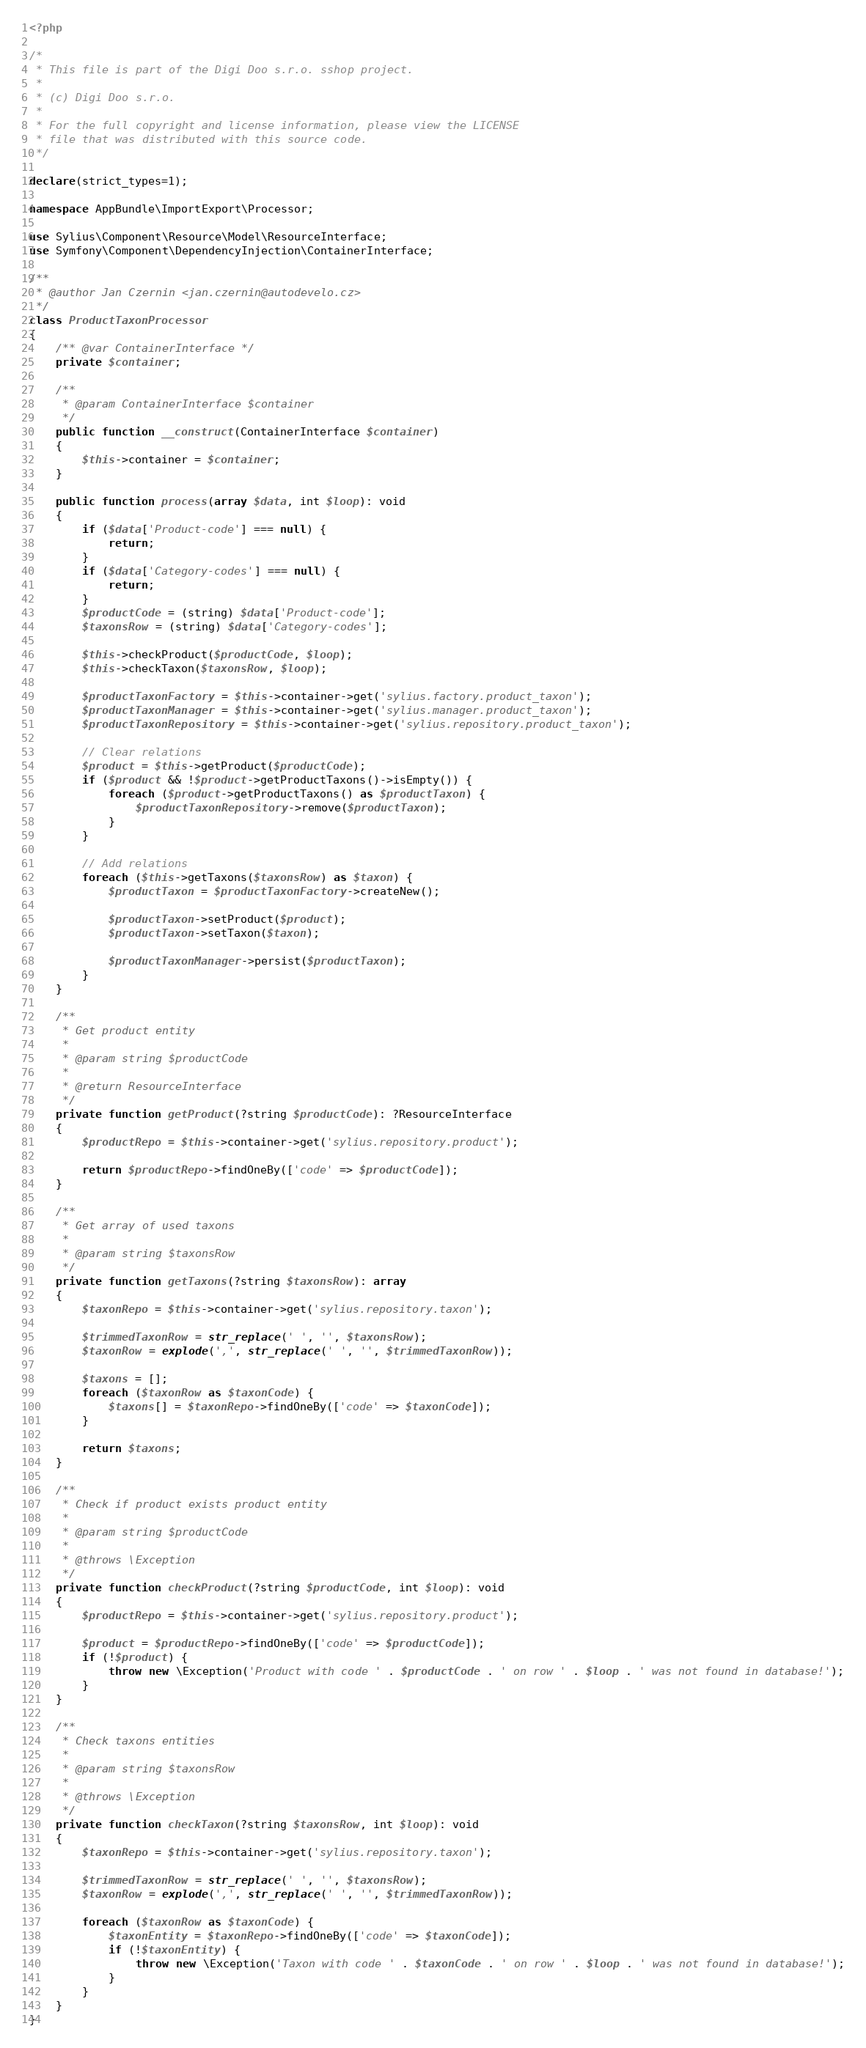Convert code to text. <code><loc_0><loc_0><loc_500><loc_500><_PHP_><?php

/*
 * This file is part of the Digi Doo s.r.o. sshop project.
 *
 * (c) Digi Doo s.r.o.
 *
 * For the full copyright and license information, please view the LICENSE
 * file that was distributed with this source code.
 */

declare(strict_types=1);

namespace AppBundle\ImportExport\Processor;

use Sylius\Component\Resource\Model\ResourceInterface;
use Symfony\Component\DependencyInjection\ContainerInterface;

/**
 * @author Jan Czernin <jan.czernin@autodevelo.cz>
 */
class ProductTaxonProcessor
{
    /** @var ContainerInterface */
    private $container;

    /**
     * @param ContainerInterface $container
     */
    public function __construct(ContainerInterface $container)
    {
        $this->container = $container;
    }

    public function process(array $data, int $loop): void
    {
        if ($data['Product-code'] === null) {
            return;
        }
        if ($data['Category-codes'] === null) {
            return;
        }
        $productCode = (string) $data['Product-code'];
        $taxonsRow = (string) $data['Category-codes'];

        $this->checkProduct($productCode, $loop);
        $this->checkTaxon($taxonsRow, $loop);

        $productTaxonFactory = $this->container->get('sylius.factory.product_taxon');
        $productTaxonManager = $this->container->get('sylius.manager.product_taxon');
        $productTaxonRepository = $this->container->get('sylius.repository.product_taxon');

        // Clear relations
        $product = $this->getProduct($productCode);
        if ($product && !$product->getProductTaxons()->isEmpty()) {
            foreach ($product->getProductTaxons() as $productTaxon) {
                $productTaxonRepository->remove($productTaxon);
            }
        }

        // Add relations
        foreach ($this->getTaxons($taxonsRow) as $taxon) {
            $productTaxon = $productTaxonFactory->createNew();

            $productTaxon->setProduct($product);
            $productTaxon->setTaxon($taxon);

            $productTaxonManager->persist($productTaxon);
        }
    }

    /**
     * Get product entity
     *
     * @param string $productCode
     *
     * @return ResourceInterface
     */
    private function getProduct(?string $productCode): ?ResourceInterface
    {
        $productRepo = $this->container->get('sylius.repository.product');

        return $productRepo->findOneBy(['code' => $productCode]);
    }

    /**
     * Get array of used taxons
     *
     * @param string $taxonsRow
     */
    private function getTaxons(?string $taxonsRow): array
    {
        $taxonRepo = $this->container->get('sylius.repository.taxon');

        $trimmedTaxonRow = str_replace(' ', '', $taxonsRow);
        $taxonRow = explode(',', str_replace(' ', '', $trimmedTaxonRow));

        $taxons = [];
        foreach ($taxonRow as $taxonCode) {
            $taxons[] = $taxonRepo->findOneBy(['code' => $taxonCode]);
        }

        return $taxons;
    }

    /**
     * Check if product exists product entity
     *
     * @param string $productCode
     *
     * @throws \Exception
     */
    private function checkProduct(?string $productCode, int $loop): void
    {
        $productRepo = $this->container->get('sylius.repository.product');

        $product = $productRepo->findOneBy(['code' => $productCode]);
        if (!$product) {
            throw new \Exception('Product with code ' . $productCode . ' on row ' . $loop . ' was not found in database!');
        }
    }

    /**
     * Check taxons entities
     *
     * @param string $taxonsRow
     *
     * @throws \Exception
     */
    private function checkTaxon(?string $taxonsRow, int $loop): void
    {
        $taxonRepo = $this->container->get('sylius.repository.taxon');

        $trimmedTaxonRow = str_replace(' ', '', $taxonsRow);
        $taxonRow = explode(',', str_replace(' ', '', $trimmedTaxonRow));

        foreach ($taxonRow as $taxonCode) {
            $taxonEntity = $taxonRepo->findOneBy(['code' => $taxonCode]);
            if (!$taxonEntity) {
                throw new \Exception('Taxon with code ' . $taxonCode . ' on row ' . $loop . ' was not found in database!');
            }
        }
    }
}
</code> 